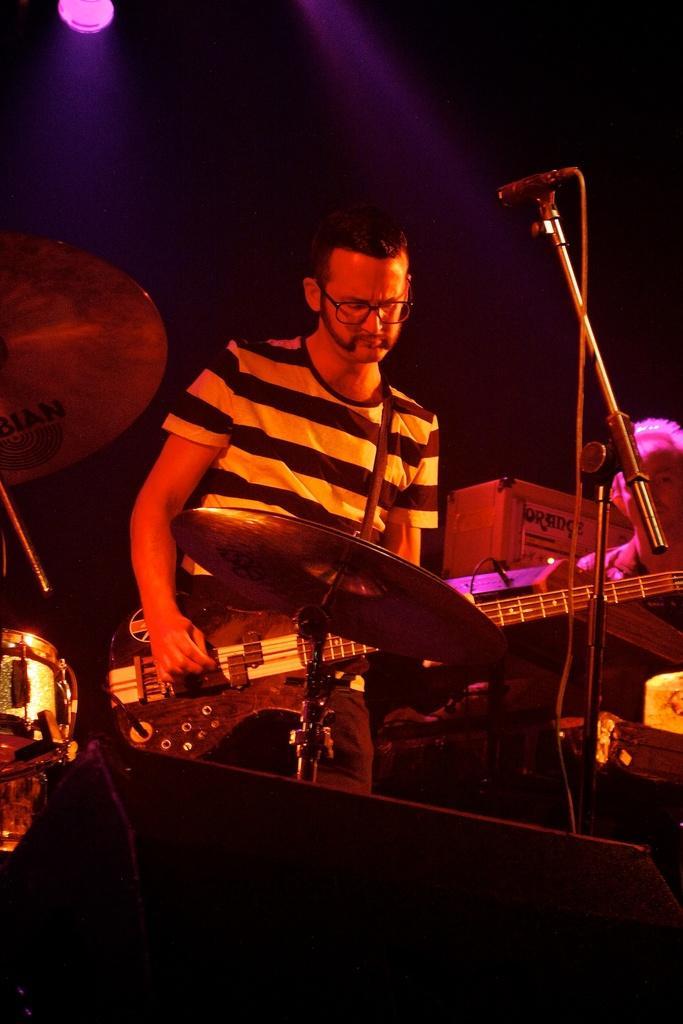Please provide a concise description of this image. This is a picture of a man holding a guitar in front of the man there is a microphone with stand and music instruments. Background of the man is in white color and a light. 